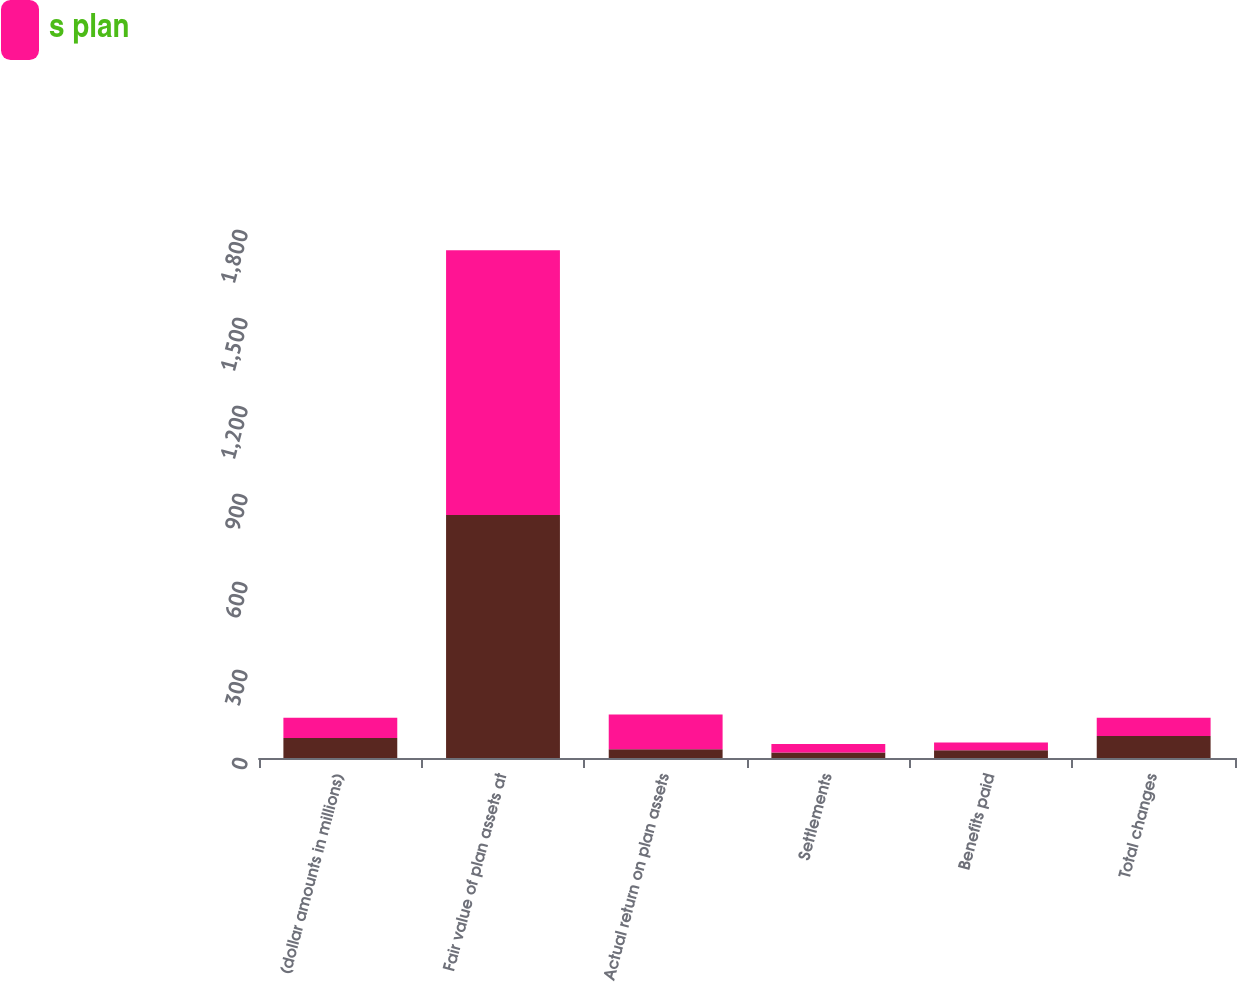Convert chart. <chart><loc_0><loc_0><loc_500><loc_500><stacked_bar_chart><ecel><fcel>(dollar amounts in millions)<fcel>Fair value of plan assets at<fcel>Actual return on plan assets<fcel>Settlements<fcel>Benefits paid<fcel>Total changes<nl><fcel>nan<fcel>68.5<fcel>828<fcel>30<fcel>19<fcel>26<fcel>75<nl><fcel>s plan<fcel>68.5<fcel>903<fcel>118<fcel>29<fcel>27<fcel>62<nl></chart> 